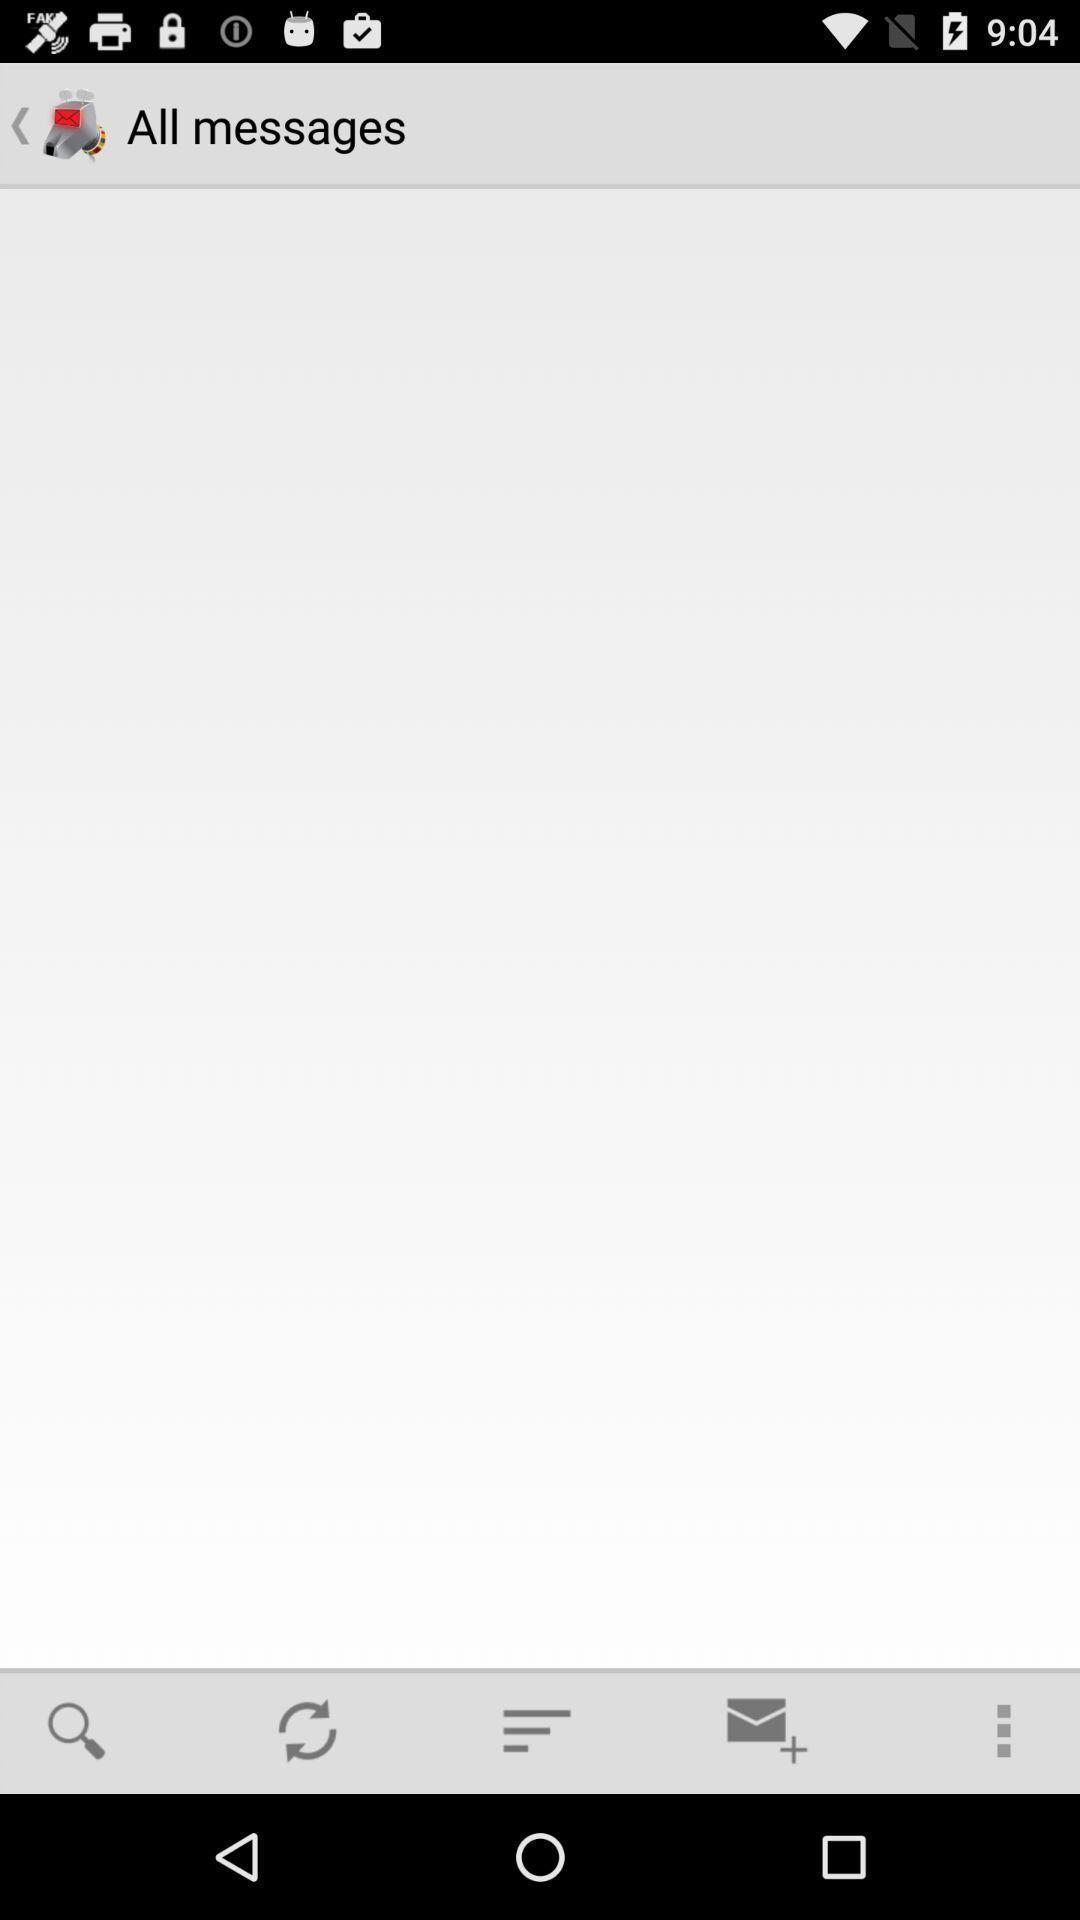Give me a summary of this screen capture. Screen displaying a chatting application. 